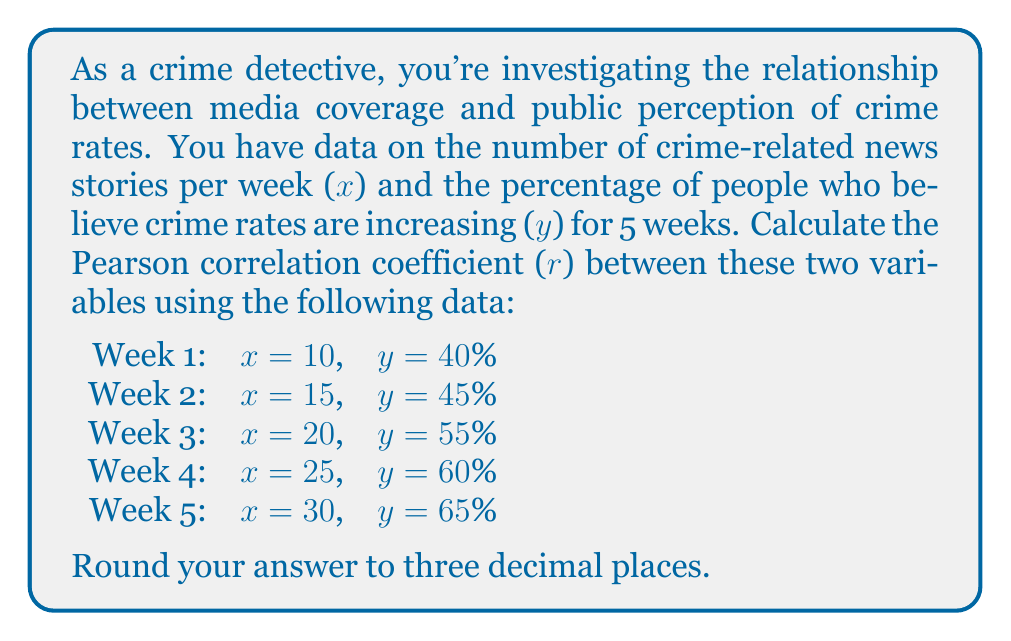Help me with this question. To calculate the Pearson correlation coefficient (r), we'll use the formula:

$$ r = \frac{n\sum xy - \sum x \sum y}{\sqrt{[n\sum x^2 - (\sum x)^2][n\sum y^2 - (\sum y)^2]}} $$

Where:
n = number of data points
x = number of crime-related news stories
y = percentage of people believing crime rates are increasing

Step 1: Calculate the necessary sums:
$\sum x = 10 + 15 + 20 + 25 + 30 = 100$
$\sum y = 40 + 45 + 55 + 60 + 65 = 265$
$\sum xy = (10 \times 40) + (15 \times 45) + (20 \times 55) + (25 \times 60) + (30 \times 65) = 5,825$
$\sum x^2 = 10^2 + 15^2 + 20^2 + 25^2 + 30^2 = 2,250$
$\sum y^2 = 40^2 + 45^2 + 55^2 + 60^2 + 65^2 = 14,475$

Step 2: Substitute values into the formula:

$$ r = \frac{5(5,825) - (100)(265)}{\sqrt{[5(2,250) - (100)^2][5(14,475) - (265)^2]}} $$

Step 3: Simplify:

$$ r = \frac{29,125 - 26,500}{\sqrt{(11,250 - 10,000)(72,375 - 70,225)}} $$

$$ r = \frac{2,625}{\sqrt{(1,250)(2,150)}} $$

$$ r = \frac{2,625}{\sqrt{2,687,500}} $$

$$ r = \frac{2,625}{1,639.055} $$

$$ r \approx 0.9914 $$

Step 4: Round to three decimal places: 0.991
Answer: 0.991 